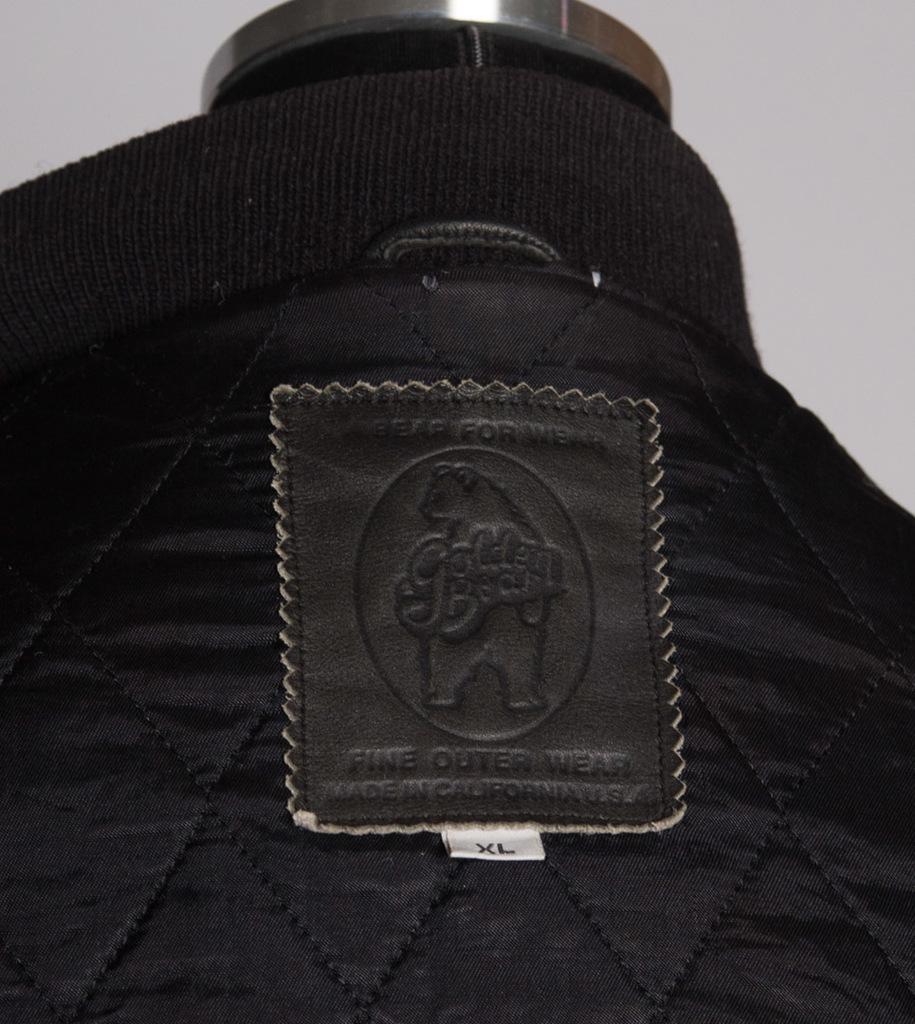Please provide a concise description of this image. This image consists of a black color cloth on which a label is attached. On the label, I can see some text. At the top of the image there is a metal object. 